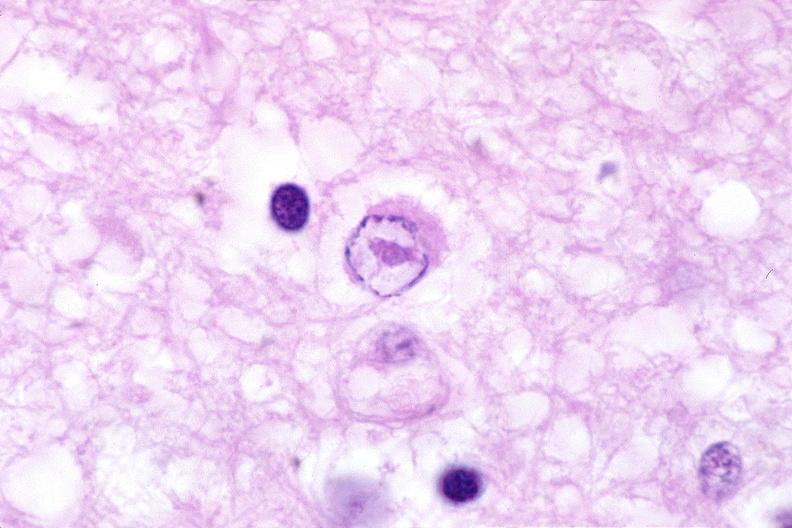s nervous present?
Answer the question using a single word or phrase. Yes 